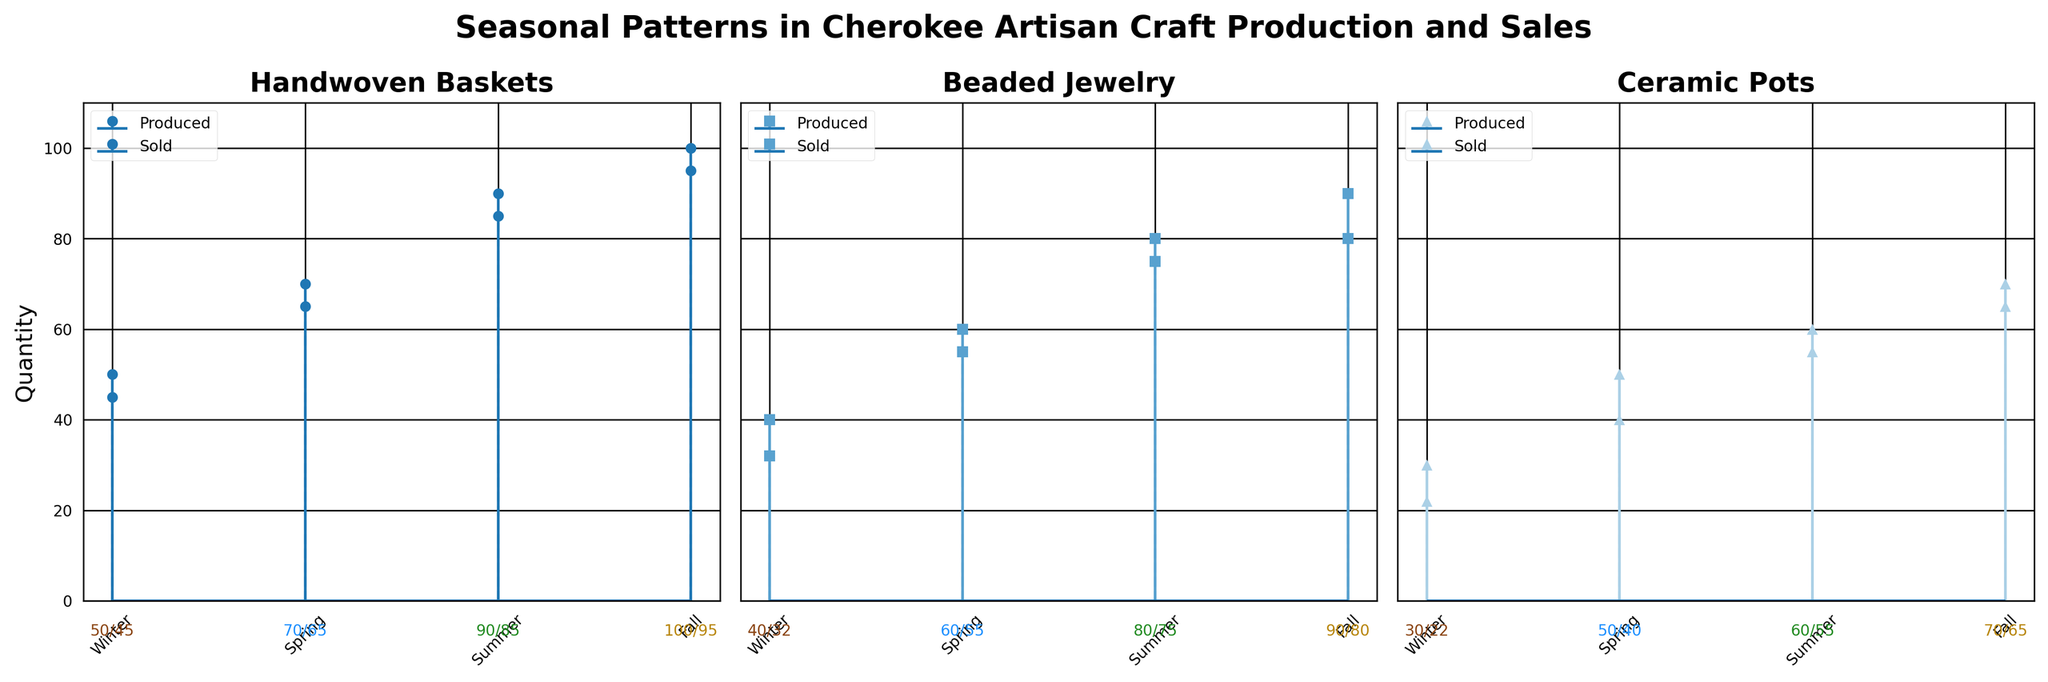What's the total quantity of Handwoven Baskets produced in Fall? According to the figure, the quantity of Handwoven Baskets produced in Fall is shown in the first subplot under 'Produced' for Fall. The value is marked as 100.
Answer: 100 Which product has the highest quantity sold in Winter? Look at the 'Sold' stem markers for Winter across all three subplots. Handwoven Baskets have 45, Beaded Jewelry has 32, and Ceramic Pots have 22. The highest value is for Handwoven Baskets with 45.
Answer: Handwoven Baskets What's the average number of Ceramic Pots sold in all seasons? To find the average, sum the quantity sold for Ceramic Pots across each season (22 in Winter, 40 in Spring, 55 in Summer, and 65 in Fall), then divide by 4. The calculation is (22 + 40 + 55 + 65) / 4 = 182 / 4 = 45.5.
Answer: 45.5 Is the difference between quantities produced and sold in Summer greater for Beaded Jewelry or Handwoven Baskets? For Beaded Jewelry in Summer, the difference is 80 (produced) - 75 (sold) = 5. For Handwoven Baskets in Summer, the difference is 90 (produced) - 85 (sold) = 5. Both products have the same difference of 5.
Answer: It's equal During which season do we observe the biggest difference between the quantities produced and sold for Ceramic Pots? The differences for each season are: Winter 30 - 22 = 8, Spring 50 - 40 = 10, Summer 60 - 55 = 5, Fall 70 - 65 = 5. The biggest difference is in Spring with a difference of 10.
Answer: Spring Which season shows a higher quantity of Beaded Jewelry sold compared to Ceramic Pots sold? Compare the quantities sold for Beaded Jewelry and Ceramic Pots in each season. In Spring, Summer, and Fall, Beaded Jewelry sold more (55 vs. 40, 75 vs. 55, and 80 vs. 65, respectively). Winter doesn't fit this criteria.
Answer: Spring, Summer, Fall What's the total quantity produced across all products in Summer? Sum the quantities produced for all products in Summer. Handwoven Baskets: 90, Beaded Jewelry: 80, Ceramic Pots: 60. The total is 90 + 80 + 60 = 230.
Answer: 230 Which season has the lowest total quantity sold across all products? Sum the quantities sold for all products in each season: Winter 45 + 32 + 22 = 99, Spring 65 + 55 + 40 = 160, Summer 85 + 75 + 55 = 215, Fall 95 + 80 + 65 = 240. The lowest total is in Winter with 99.
Answer: Winter What percentage increase in quantity of Handwoven Baskets produced can be seen from Winter to Summer? Winter production is 50 and Summer production is 90. The percentage increase is calculated as ((90 - 50) / 50) * 100 = (40 / 50) * 100 = 80%.
Answer: 80% 